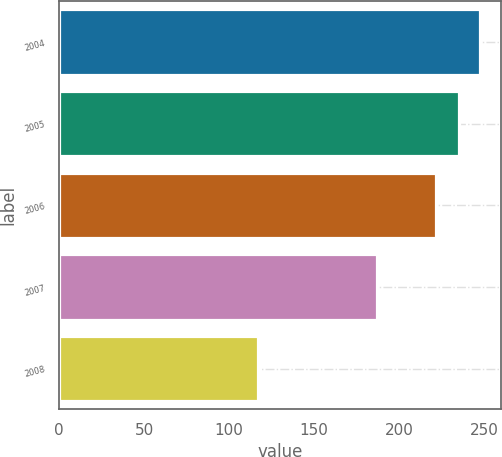<chart> <loc_0><loc_0><loc_500><loc_500><bar_chart><fcel>2004<fcel>2005<fcel>2006<fcel>2007<fcel>2008<nl><fcel>247.6<fcel>235<fcel>222<fcel>187<fcel>117<nl></chart> 